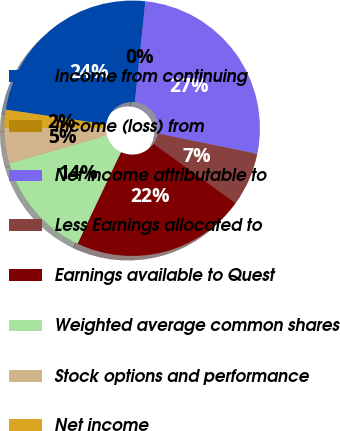Convert chart. <chart><loc_0><loc_0><loc_500><loc_500><pie_chart><fcel>Income from continuing<fcel>Income (loss) from<fcel>Net income attributable to<fcel>Less Earnings allocated to<fcel>Earnings available to Quest<fcel>Weighted average common shares<fcel>Stock options and performance<fcel>Net income<nl><fcel>24.32%<fcel>0.0%<fcel>26.57%<fcel>6.76%<fcel>22.06%<fcel>13.53%<fcel>4.51%<fcel>2.25%<nl></chart> 